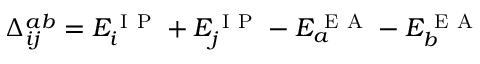<formula> <loc_0><loc_0><loc_500><loc_500>\Delta _ { i j } ^ { a b } = E _ { i } ^ { I P } + E _ { j } ^ { I P } - E _ { a } ^ { E A } - E _ { b } ^ { E A }</formula> 